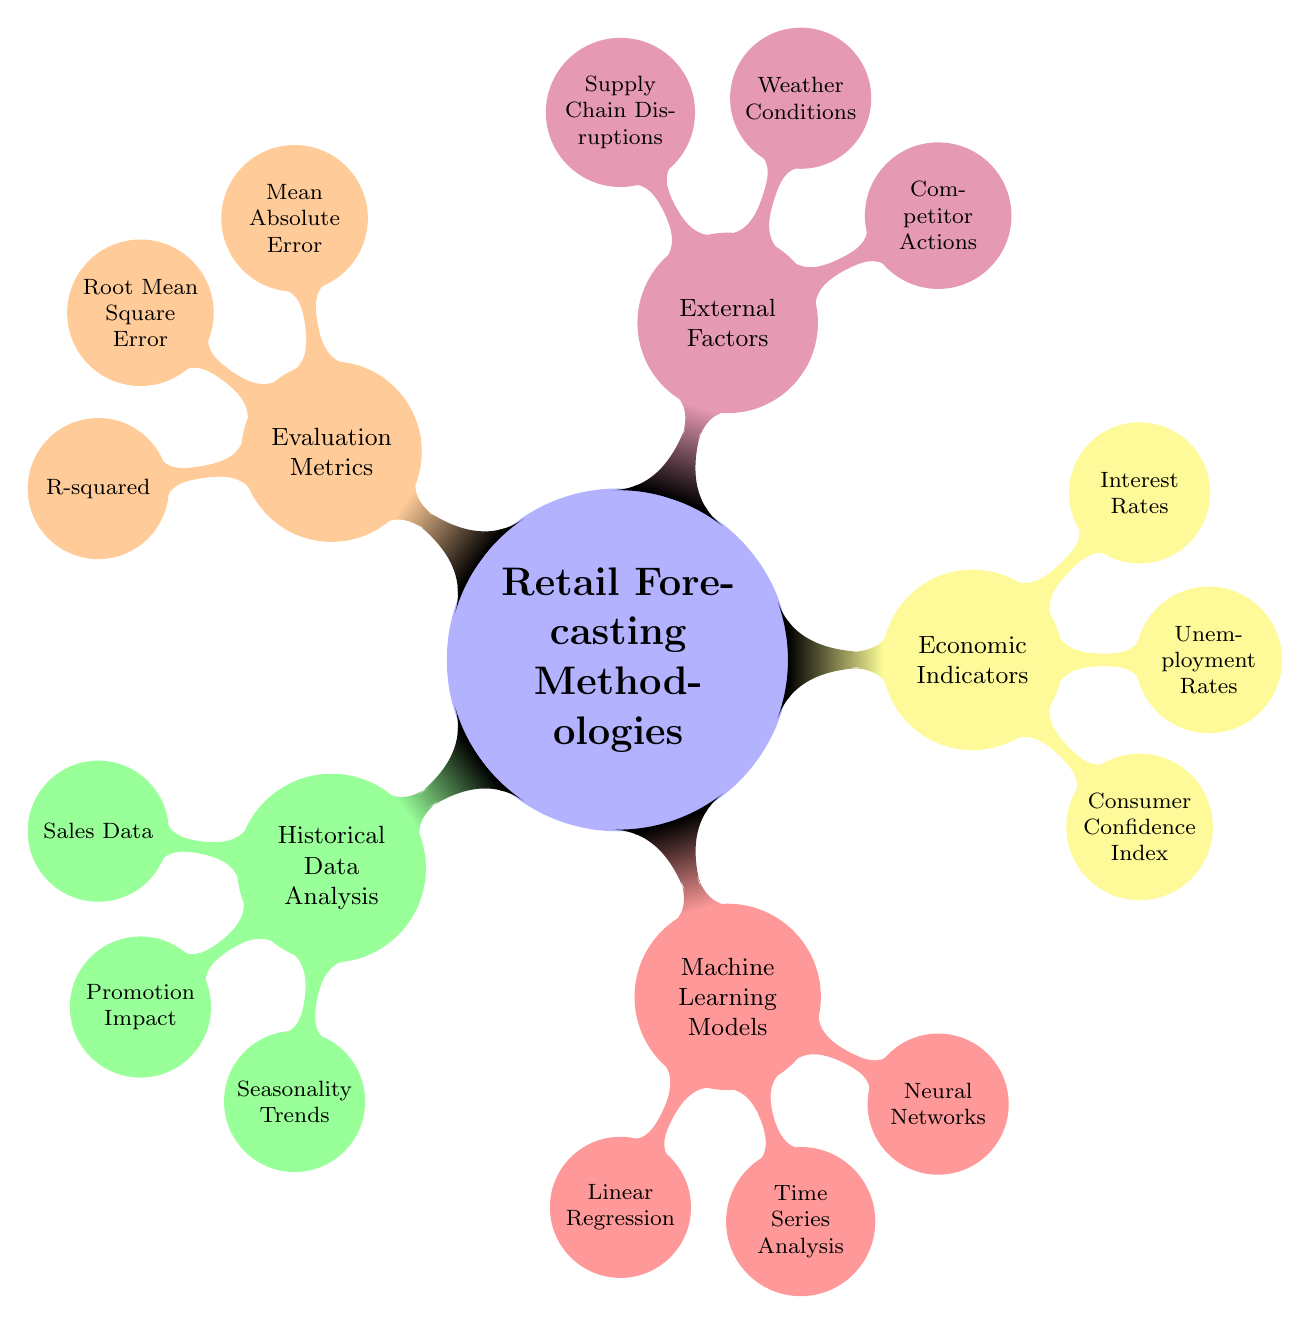what are the main categories in retail forecasting methodologies? The diagram presents five main categories: Historical Data Analysis, Machine Learning Models, Economic Indicators, External Factors, and Evaluation Metrics. Each category is represented as a child node under the main topic.
Answer: Historical Data Analysis, Machine Learning Models, Economic Indicators, External Factors, Evaluation Metrics how many nodes are there under the Economic Indicators category? Under the Economic Indicators category, there are three child nodes: Consumer Confidence Index, Unemployment Rates, and Interest Rates. This can be counted directly by looking at the nodes branching from the Economic Indicators node.
Answer: 3 which methodology includes Time Series Analysis? The Time Series Analysis node is a child of the Machine Learning Models category. By following the branches from the main category to the specific node, you can identify that Time Series Analysis belongs to Machine Learning Models.
Answer: Machine Learning Models what evaluation metric focuses on prediction accuracy? The evaluation metric that measures prediction accuracy is Mean Absolute Error, which is one of the three metrics listed under the Evaluation Metrics category. It can be identified by finding the node directly under the Evaluation Metrics category that describes accuracy.
Answer: Mean Absolute Error which external factor affects sales through inventory issues? Supply Chain Disruptions is the external factor that impacts sales due to delays and inventory problems. This can be seen directly by examining the child nodes under the External Factors category.
Answer: Supply Chain Disruptions which two machine learning models utilize sales time series data? The two machine learning models that use sales time series data are Time Series Analysis and Neural Networks. To answer this, you first identify the models within the Machine Learning Models category and consider which models can work with time series data.
Answer: Time Series Analysis, Neural Networks how does the Consumer Confidence Index influence retail forecasting? The Consumer Confidence Index impacts retail forecasting by gauging consumer trends, which can lead to changes in purchasing behaviors. This relationship can be derived by understanding the purpose of the Consumer Confidence Index as indicated in the Economic Indicators category.
Answer: Gauge consumer trends what type of relationship does Linear Regression analyze in sales data? Linear Regression analyzes linear relationships in sales data. This is indicated directly in the Machine Learning Models category where Linear Regression is defined.
Answer: Linear relationships 